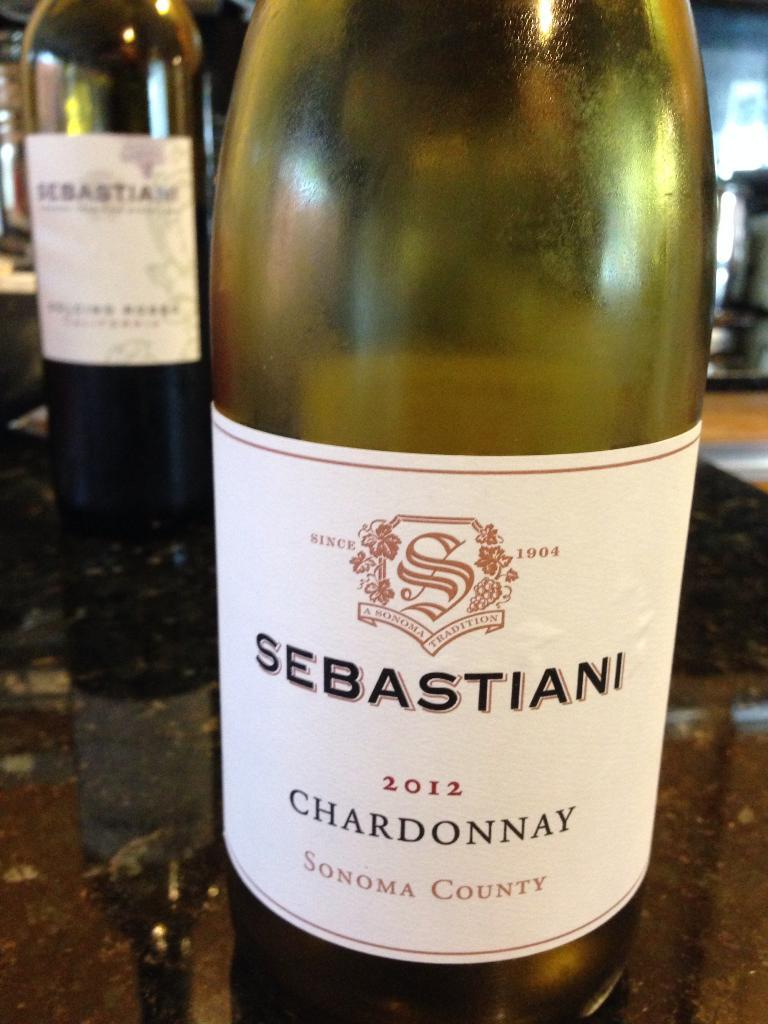How many bottles are on the table in the image? There are two bottles on the table in the image. What can be observed on the bottles? The bottles have white color stickers on them. What type of gold match can be seen in the image? There is no gold match present in the image. 